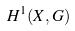Convert formula to latex. <formula><loc_0><loc_0><loc_500><loc_500>H ^ { 1 } ( X , G )</formula> 